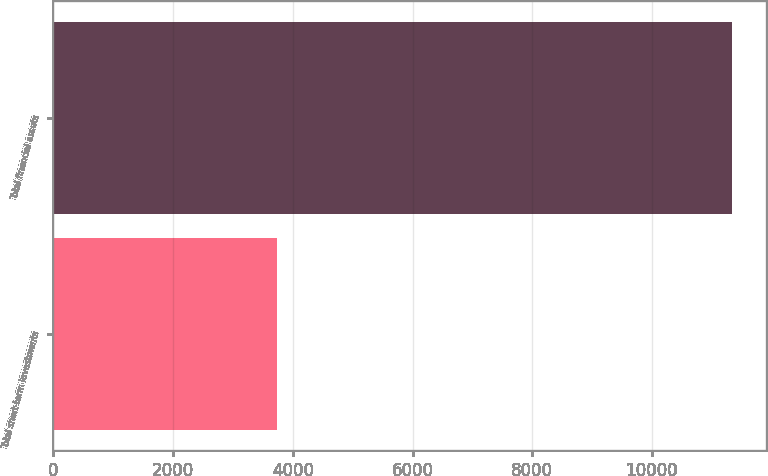Convert chart. <chart><loc_0><loc_0><loc_500><loc_500><bar_chart><fcel>Total short-term investments<fcel>Total financial assets<nl><fcel>3743<fcel>11337<nl></chart> 